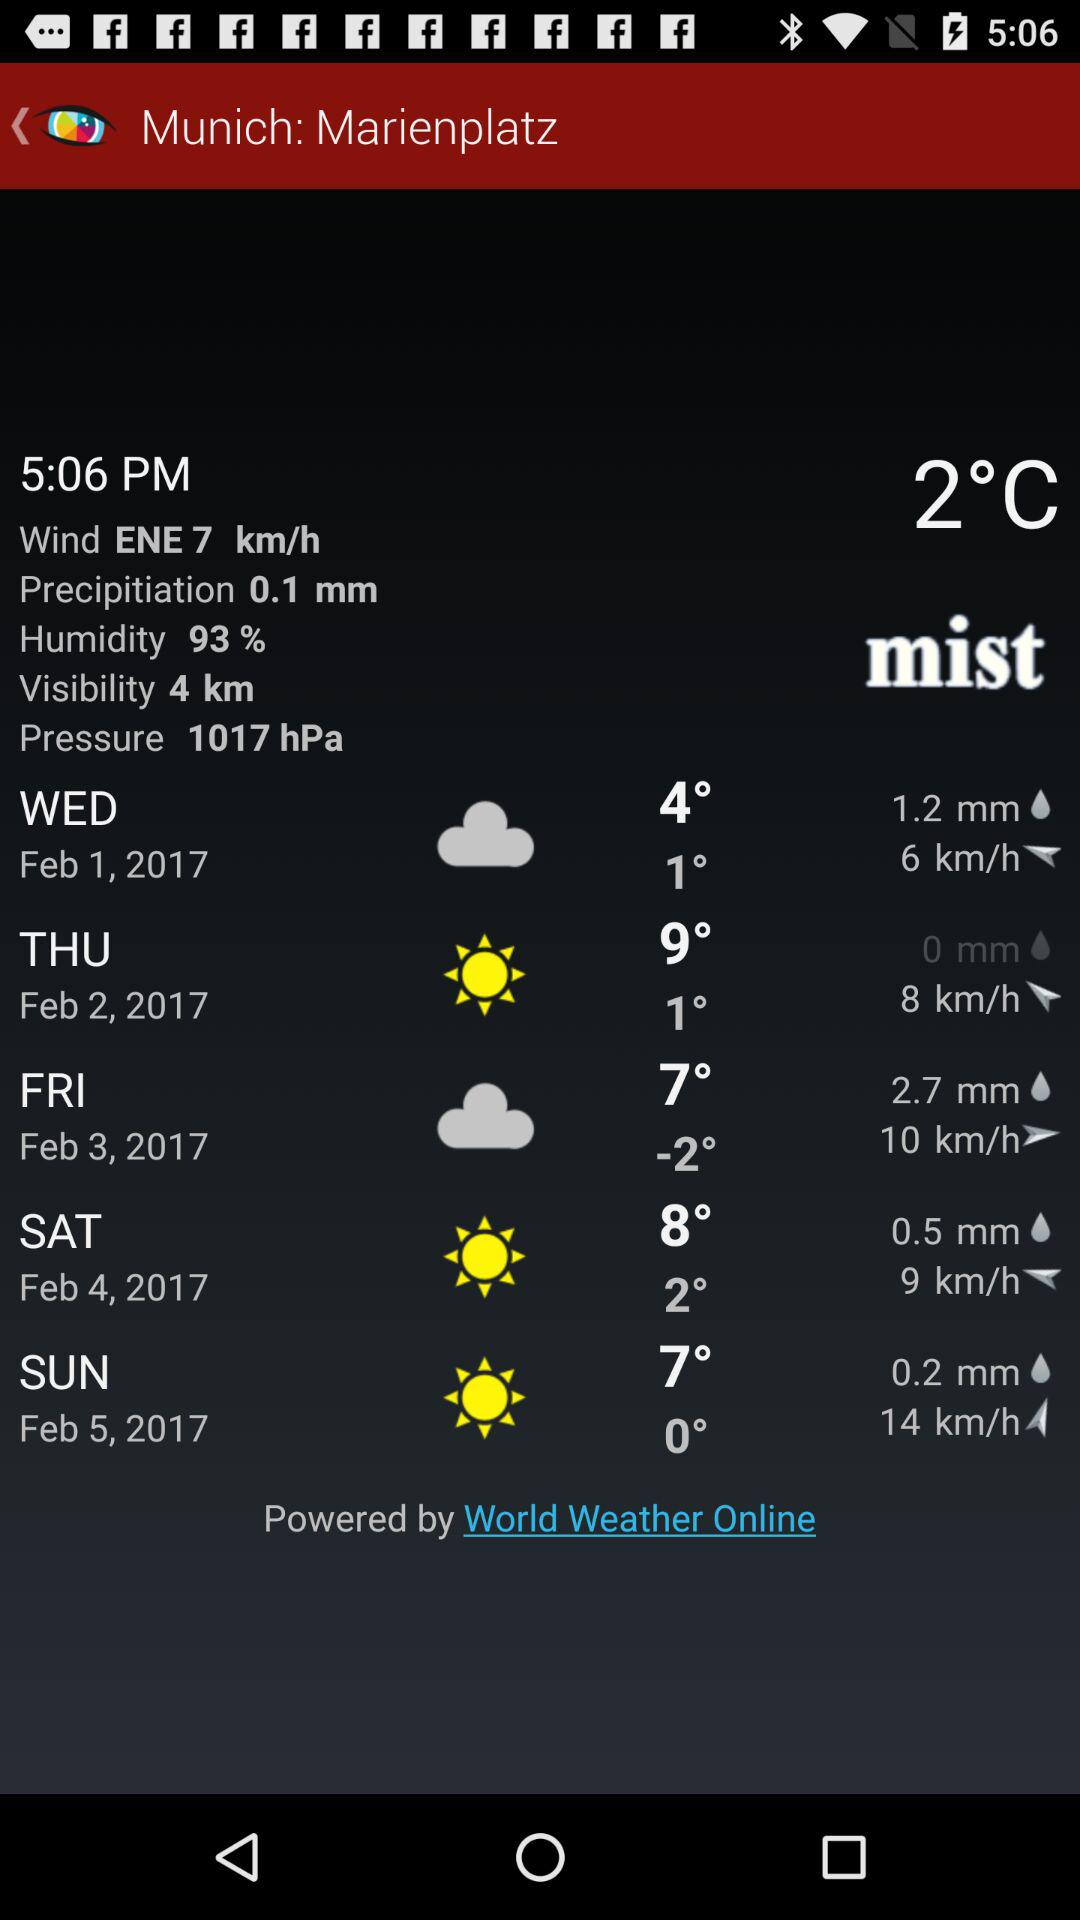What is the date on Saturday? The date on Saturday is February 4, 2017. 